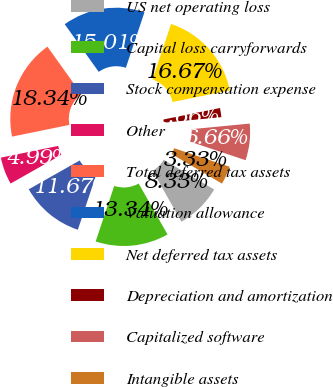Convert chart. <chart><loc_0><loc_0><loc_500><loc_500><pie_chart><fcel>US net operating loss<fcel>Capital loss carryforwards<fcel>Stock compensation expense<fcel>Other<fcel>Total deferred tax assets<fcel>Valuation allowance<fcel>Net deferred tax assets<fcel>Depreciation and amortization<fcel>Capitalized software<fcel>Intangible assets<nl><fcel>8.33%<fcel>13.34%<fcel>11.67%<fcel>4.99%<fcel>18.34%<fcel>15.01%<fcel>16.67%<fcel>1.66%<fcel>6.66%<fcel>3.33%<nl></chart> 